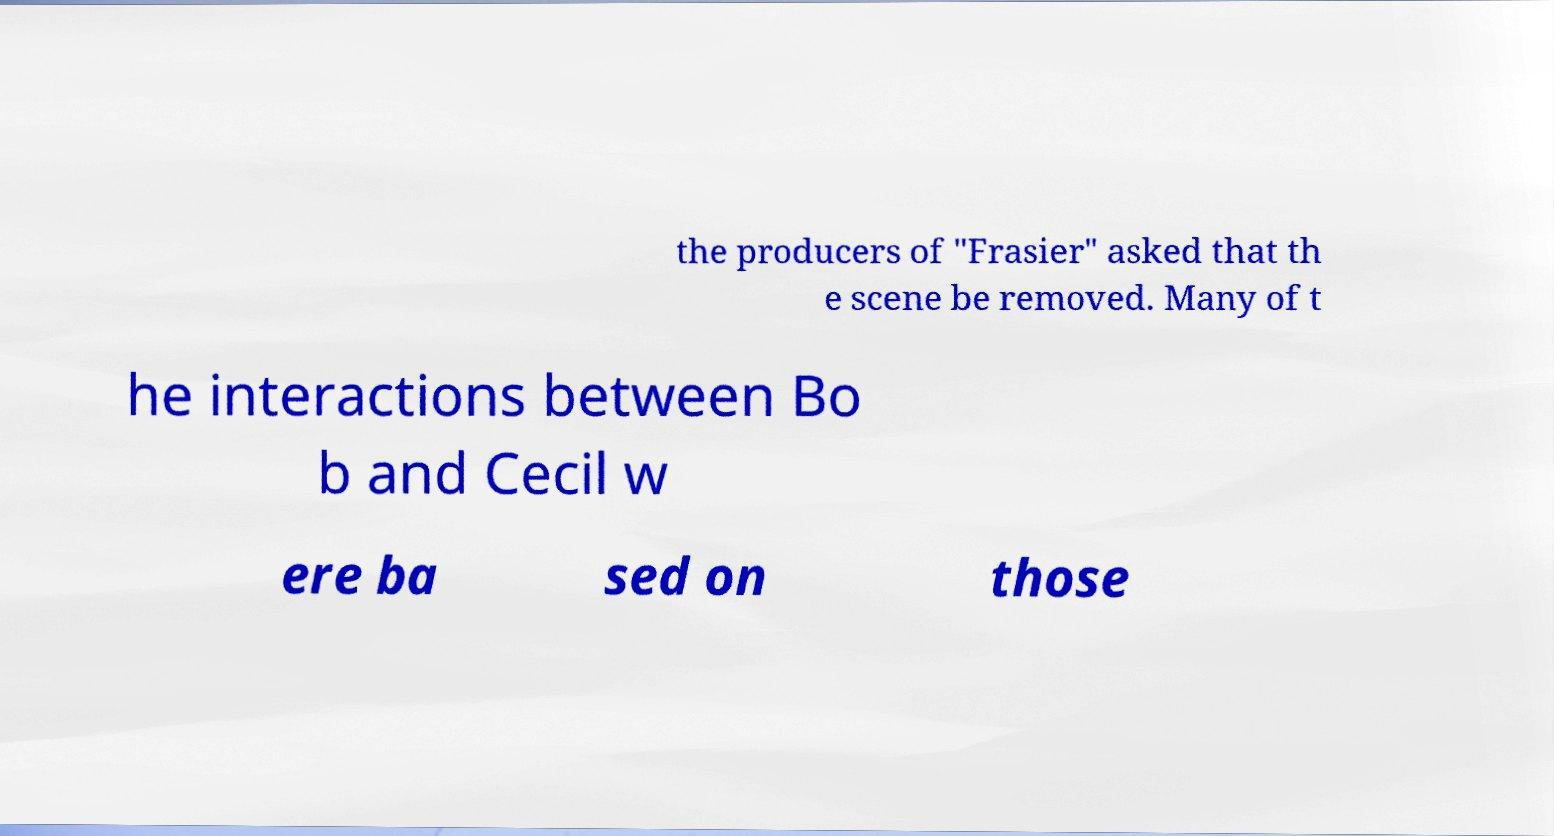I need the written content from this picture converted into text. Can you do that? the producers of "Frasier" asked that th e scene be removed. Many of t he interactions between Bo b and Cecil w ere ba sed on those 